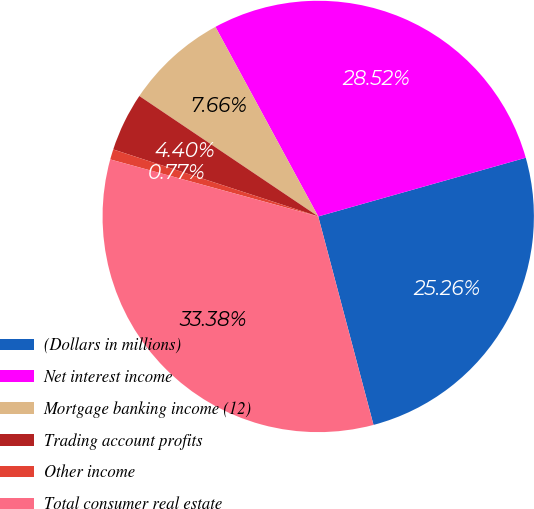<chart> <loc_0><loc_0><loc_500><loc_500><pie_chart><fcel>(Dollars in millions)<fcel>Net interest income<fcel>Mortgage banking income (12)<fcel>Trading account profits<fcel>Other income<fcel>Total consumer real estate<nl><fcel>25.26%<fcel>28.52%<fcel>7.66%<fcel>4.4%<fcel>0.77%<fcel>33.38%<nl></chart> 